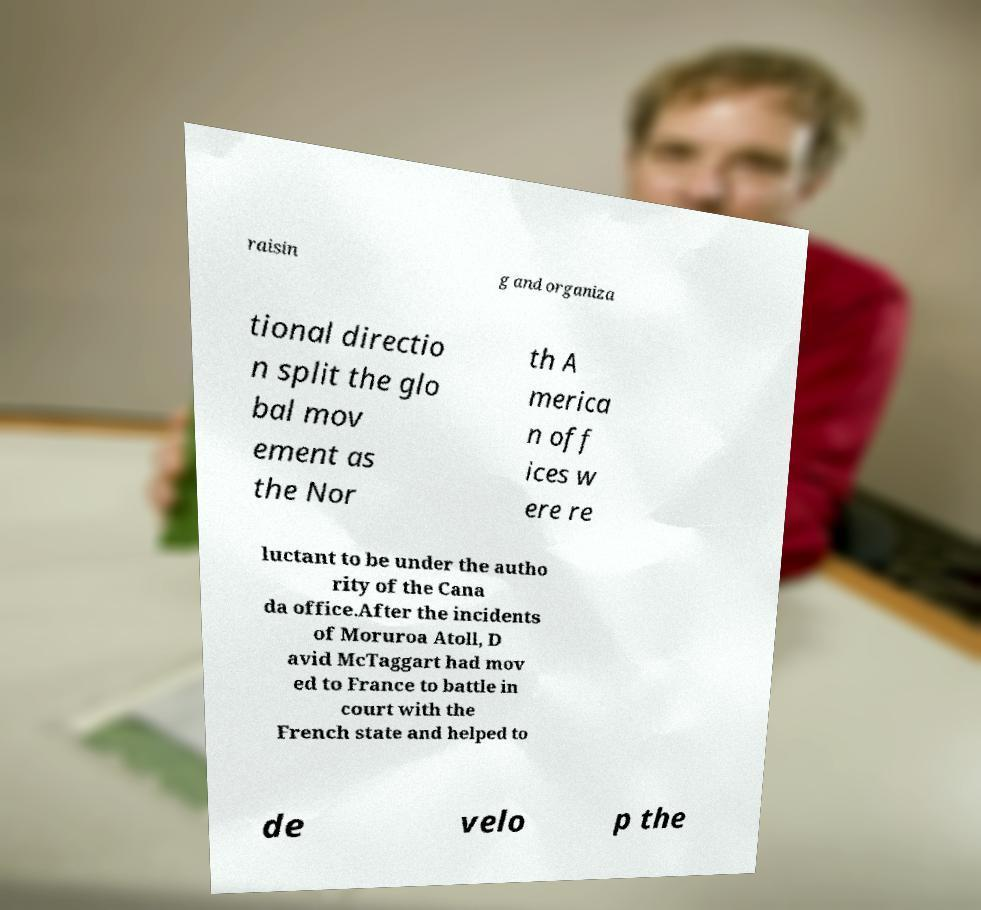Can you accurately transcribe the text from the provided image for me? raisin g and organiza tional directio n split the glo bal mov ement as the Nor th A merica n off ices w ere re luctant to be under the autho rity of the Cana da office.After the incidents of Moruroa Atoll, D avid McTaggart had mov ed to France to battle in court with the French state and helped to de velo p the 